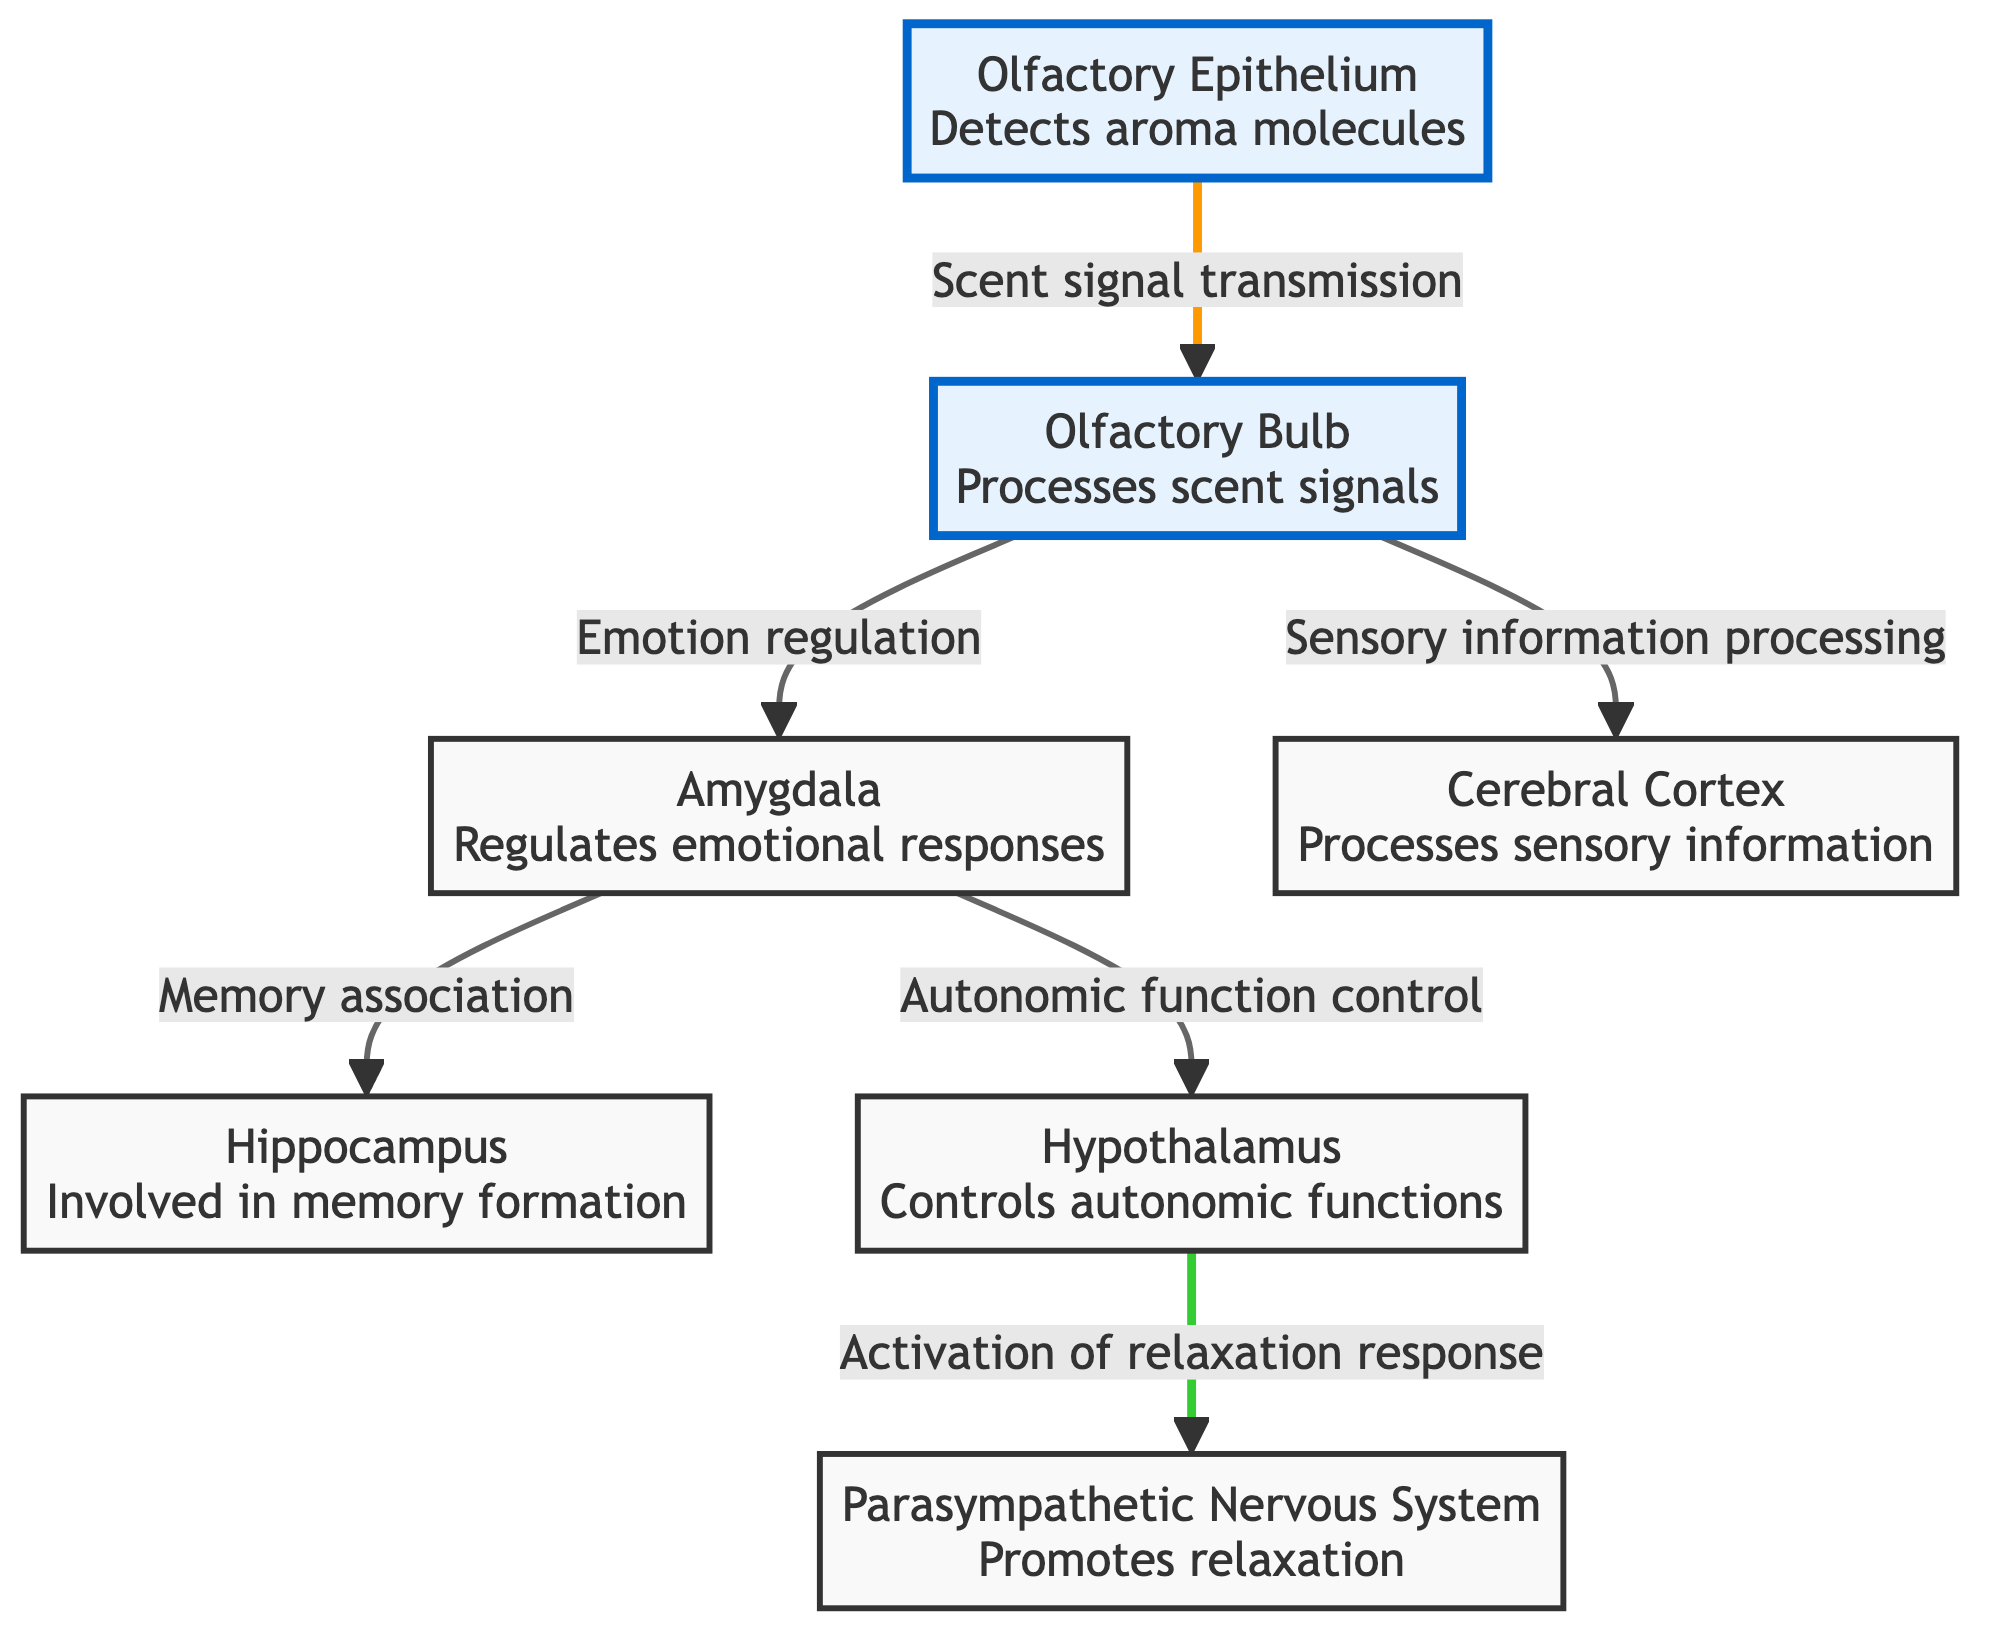What is the first node in the flowchart? The first node is "Olfactory Epithelium," which is where aroma molecules are detected.
Answer: Olfactory Epithelium How many nodes are in the diagram? The diagram includes a total of six nodes that represent different brain areas and functions associated with aromatherapy.
Answer: 6 What connects the Olfactory Bulb to the Amygdala? The connection is labeled as "Emotion regulation," indicating how the Olfactory Bulb impacts emotional responses through the Amygdala.
Answer: Emotion regulation Which part of the brain is involved in memory formation? The Hippocampus is responsible for memory formation according to the diagram.
Answer: Hippocampus What function does the Parasympathetic Nervous System serve in this diagram? The diagram indicates that the Parasympathetic Nervous System promotes relaxation, which is a key response linked to aromatherapy effects.
Answer: Promotes relaxation How does the Olfactory Bulb influence the Cerebral Cortex? The Olfactory Bulb sends sensory information to the Cerebral Cortex for processing, facilitating the sensory experience of aromas.
Answer: Sensory information processing Which two areas are directly connected to the Amygdala? The areas directly connected to the Amygdala are the Hippocampus and the Hypothalamus, each serving functions related to memory and autonomic control, respectively.
Answer: Hippocampus, Hypothalamus What is the role of the Hypothalamus in the relaxation process? The Hypothalamus controls autonomic functions and activates the relaxation response, making it crucial in the sensation of relaxation induced by aromatherapy.
Answer: Controls autonomic functions How does the flow of information progress from aroma detection to relaxation? The flow starts at the Olfactory Epithelium, moves to the Olfactory Bulb, then to the Amygdala for emotion regulation and the Hippocampus for memory, branching to the Hypothalamus, which activates the Parasympathetic Nervous System for relaxation.
Answer: Olfactory Epithelium → Olfactory Bulb → Amygdala → Hippocampus, Hypothalamus → Parasympathetic Nervous System 